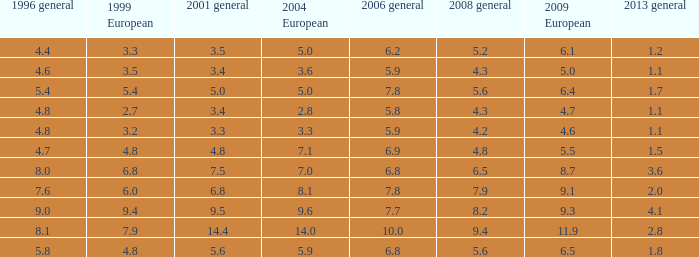What was the importance for 2004 european with less 3.6, 2.8. 